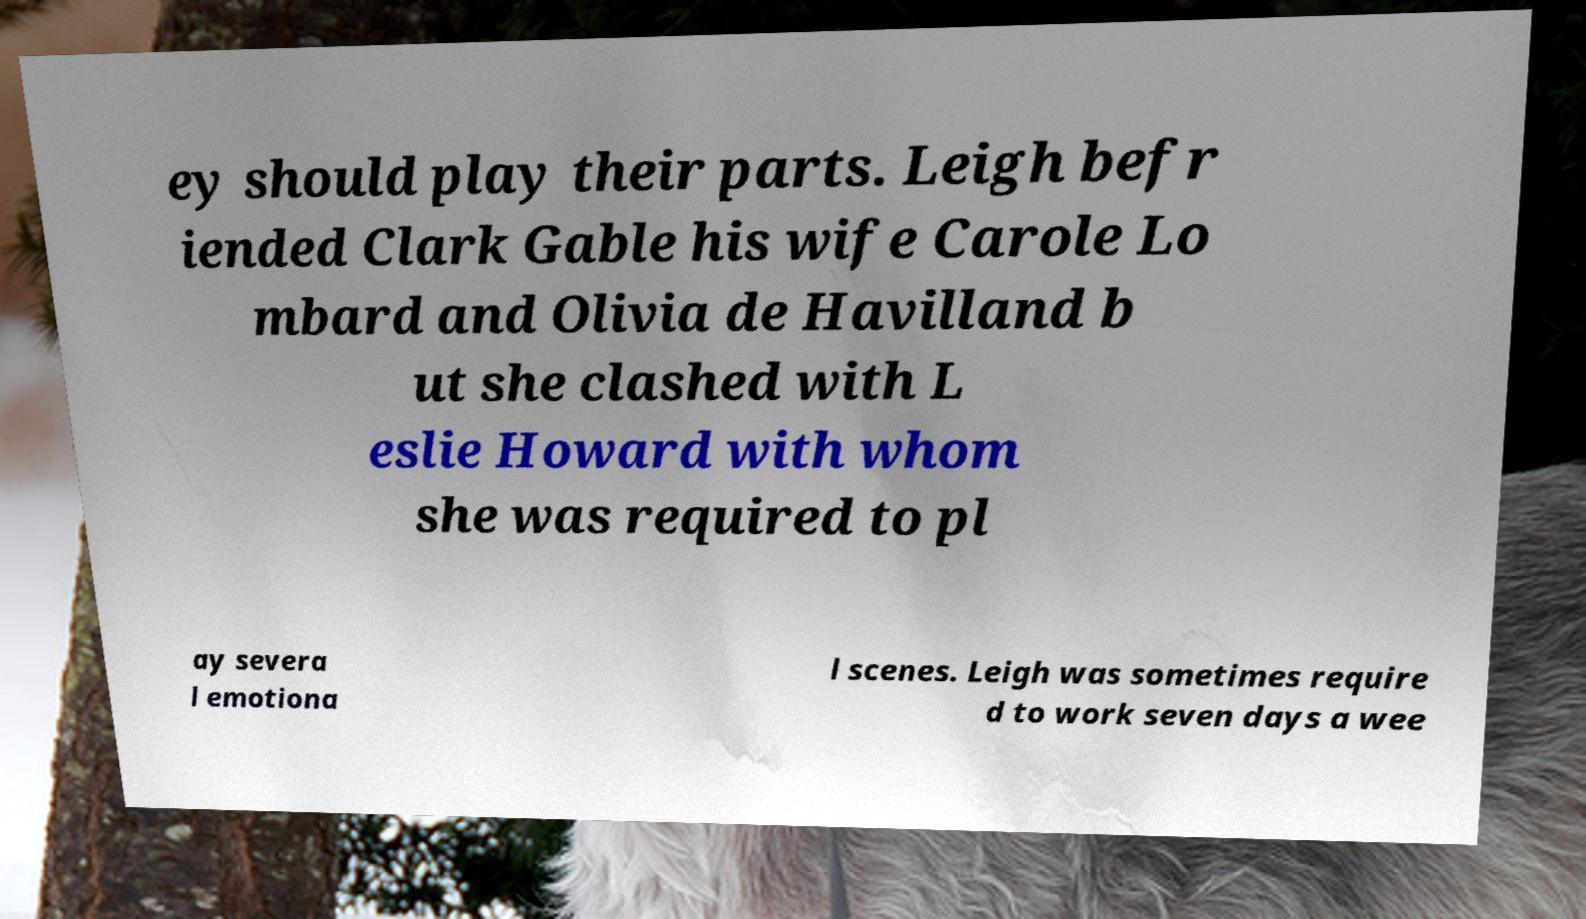Could you extract and type out the text from this image? ey should play their parts. Leigh befr iended Clark Gable his wife Carole Lo mbard and Olivia de Havilland b ut she clashed with L eslie Howard with whom she was required to pl ay severa l emotiona l scenes. Leigh was sometimes require d to work seven days a wee 